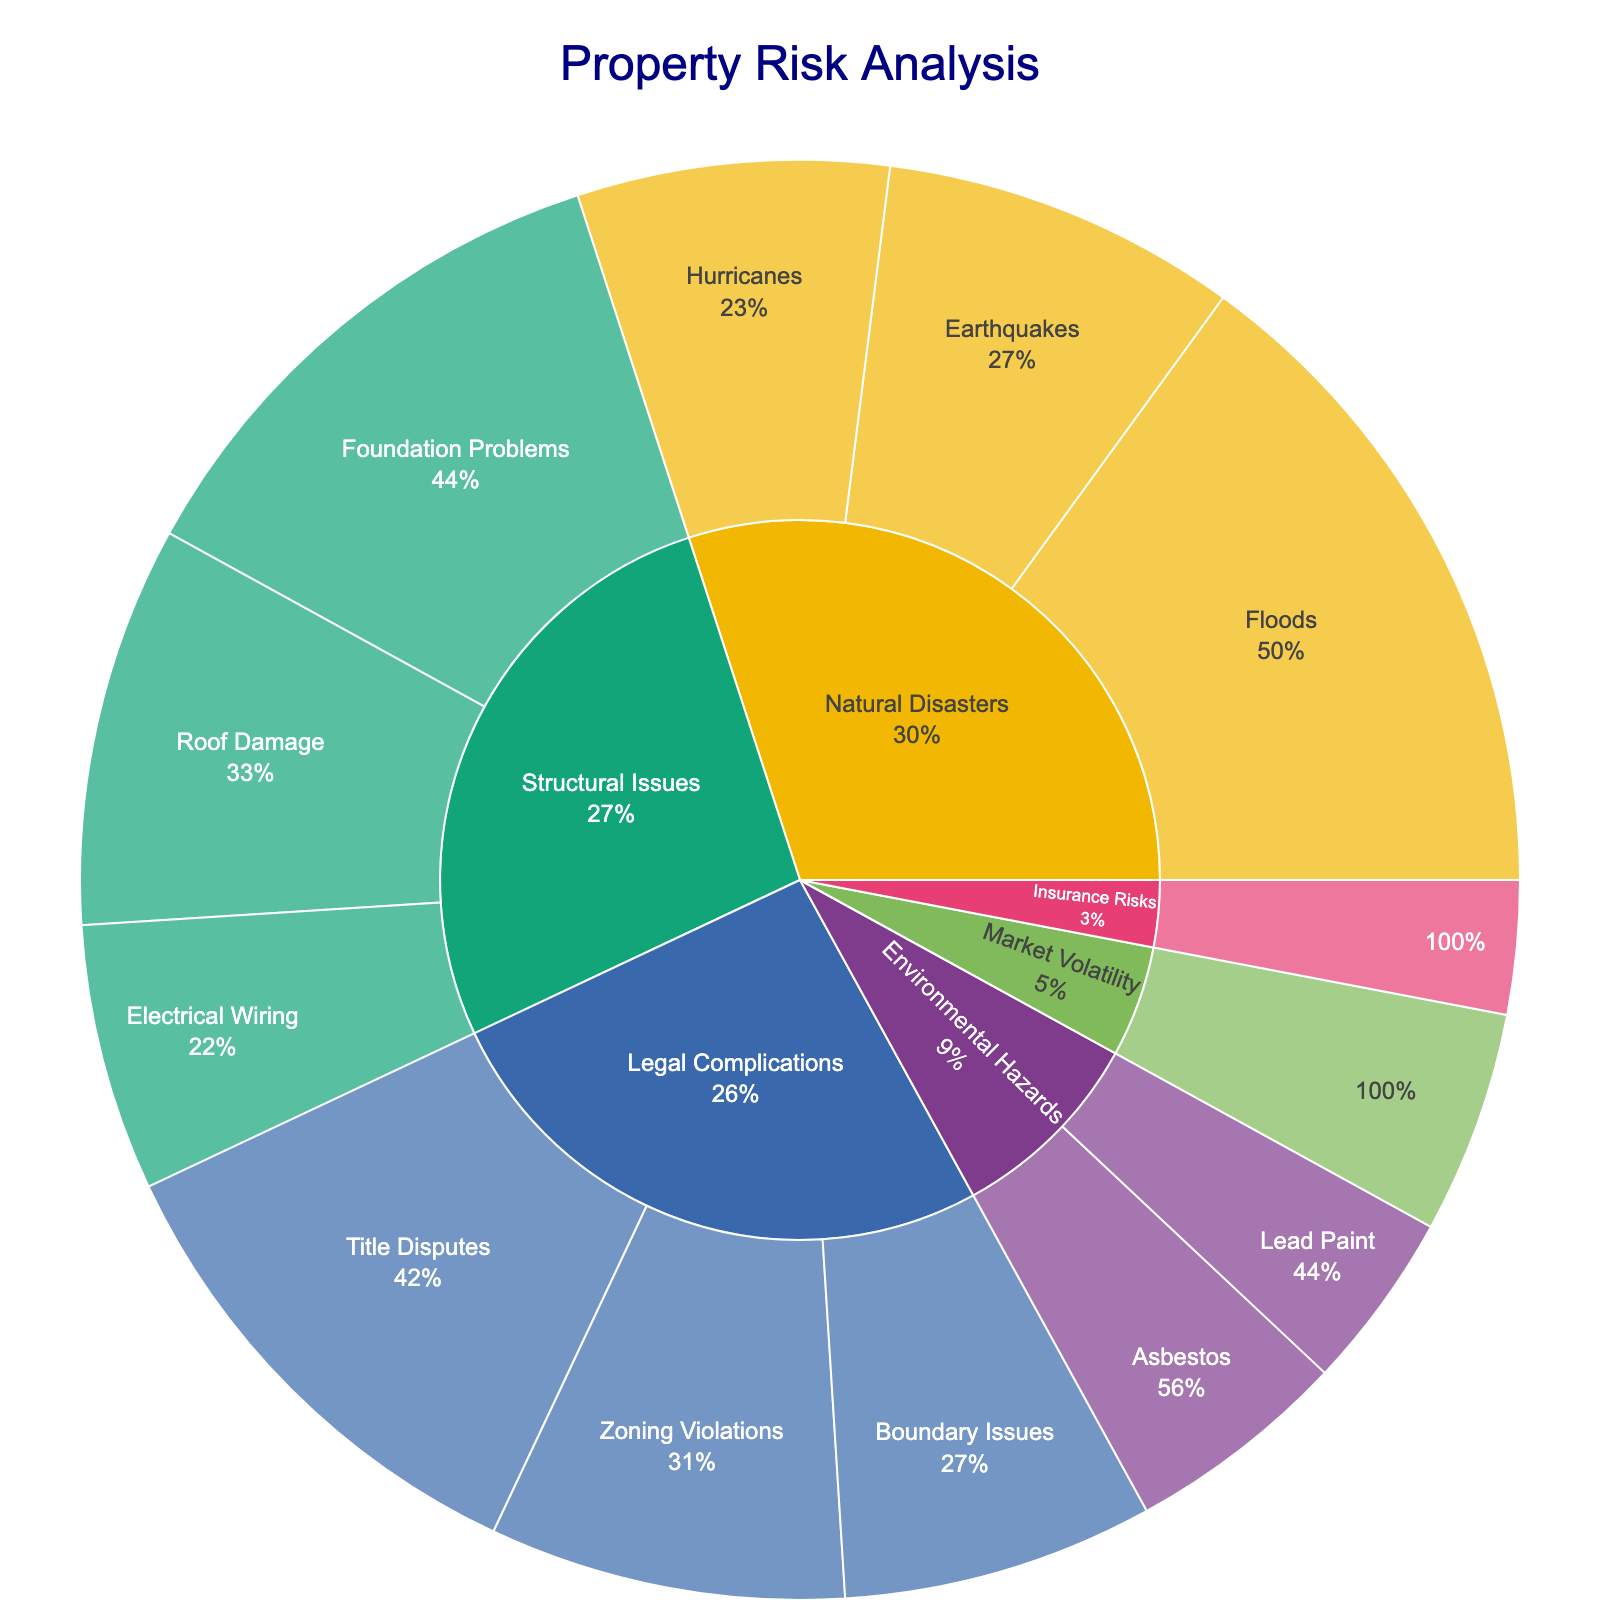Which type of natural disaster poses the highest risk? The figure has multiple subcategories under the "Natural Disasters" category. Compare the percentages for floods, earthquakes, and hurricanes. Floods have the highest percentage at 15%.
Answer: Floods What percentage of risks are due to structural issues in total? Sum the percentages of all subcategories under "Structural Issues": foundation problems (12%), roof damage (9%), and electrical wiring (6%). 12 + 9 + 6 = 27%.
Answer: 27% Which category has the least percentage of risks? Compare the total percentages of all primary categories: Natural Disasters, Structural Issues, Legal Complications, Environmental Hazards, Market Volatility, and Insurance Risks. Insurance Risks have the lowest percentage at 3%.
Answer: Insurance Risks What is the percentage difference between risks from foundation problems and roof damage? Subtract the percentage of roof damage (9%) from foundation problems (12%). 12 - 9 = 3%.
Answer: 3% How do the risks from legal complications compare with those from environmental hazards? Sum the percentages of all subcategories under "Legal Complications" and "Environmental Hazards". Legal Complications: title disputes (11%), zoning violations (8%), boundary issues (7%) = 11 + 8 + 7 = 26%. Environmental Hazards: asbestos (5%), lead paint (4%) = 5 + 4 = 9%. Legal complications pose a higher risk at 26% compared to 9% for environmental hazards.
Answer: Legal complications pose higher risk What's the combined risk percentage for both environmental hazards and market volatility? Sum the percentages of all subcategories under "Environmental Hazards" and "Market Volatility". Environmental Hazards: asbestos (5%), lead paint (4%) = 5 + 4. Market Volatility: 5%. 5 + 4 + 5 = 14%.
Answer: 14% Which subcategory under structural issues contributes the least to the overall percentage of risks? Compare percentages of all subcategories under "Structural Issues". Electrical wiring has the least at 6%.
Answer: Electrical wiring By how much do risks from zoning violations and boundary issues add up to the risks from title disputes? Sum the percentages for zoning violations (8%) and boundary issues (7%), then compare this sum to the percentage for title disputes (11%). 8 + 7 = 15% vs 11%. The combined risks from zoning violations and boundary issues (15%) are 4% higher than the risks from title disputes (11%).
Answer: 4% What's the total percentage of risks associated with natural disasters? Sum the percentages of all subcategories under "Natural Disasters": floods (15%), earthquakes (8%), and hurricanes (7%). 15 + 8 + 7 = 30%.
Answer: 30% What risk is more prevalent: market volatility or asbestos? Compare the percentages directly from the figure: market volatility (5%) and asbestos (5%). They are equal.
Answer: Equal 